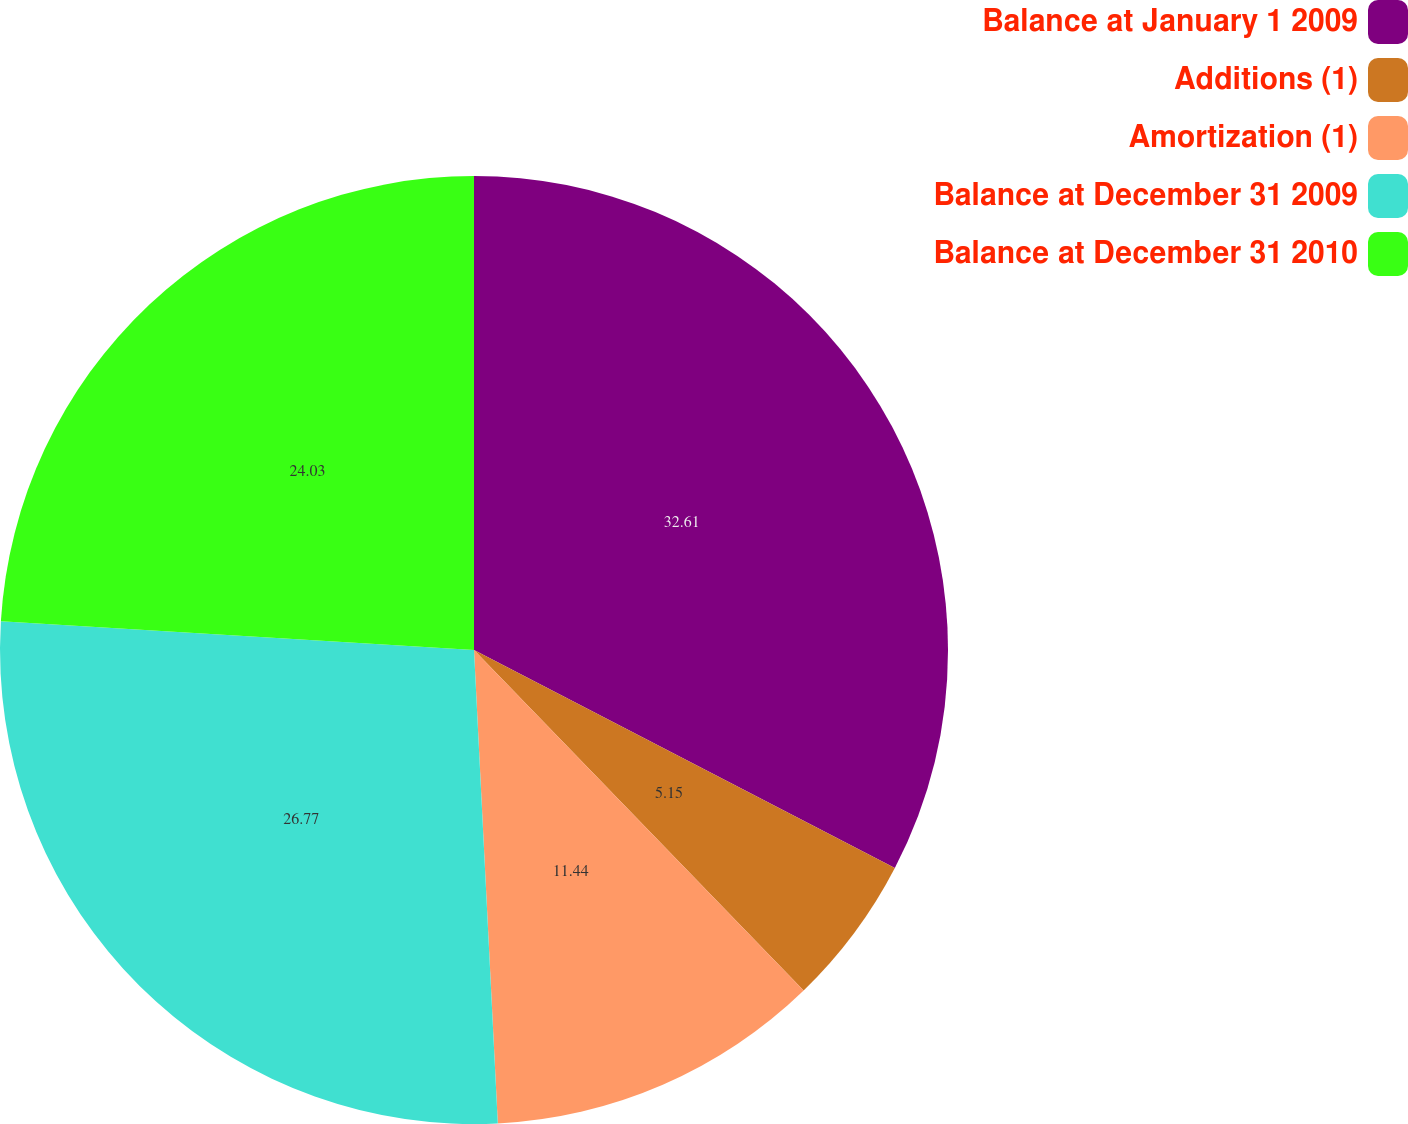Convert chart. <chart><loc_0><loc_0><loc_500><loc_500><pie_chart><fcel>Balance at January 1 2009<fcel>Additions (1)<fcel>Amortization (1)<fcel>Balance at December 31 2009<fcel>Balance at December 31 2010<nl><fcel>32.61%<fcel>5.15%<fcel>11.44%<fcel>26.77%<fcel>24.03%<nl></chart> 